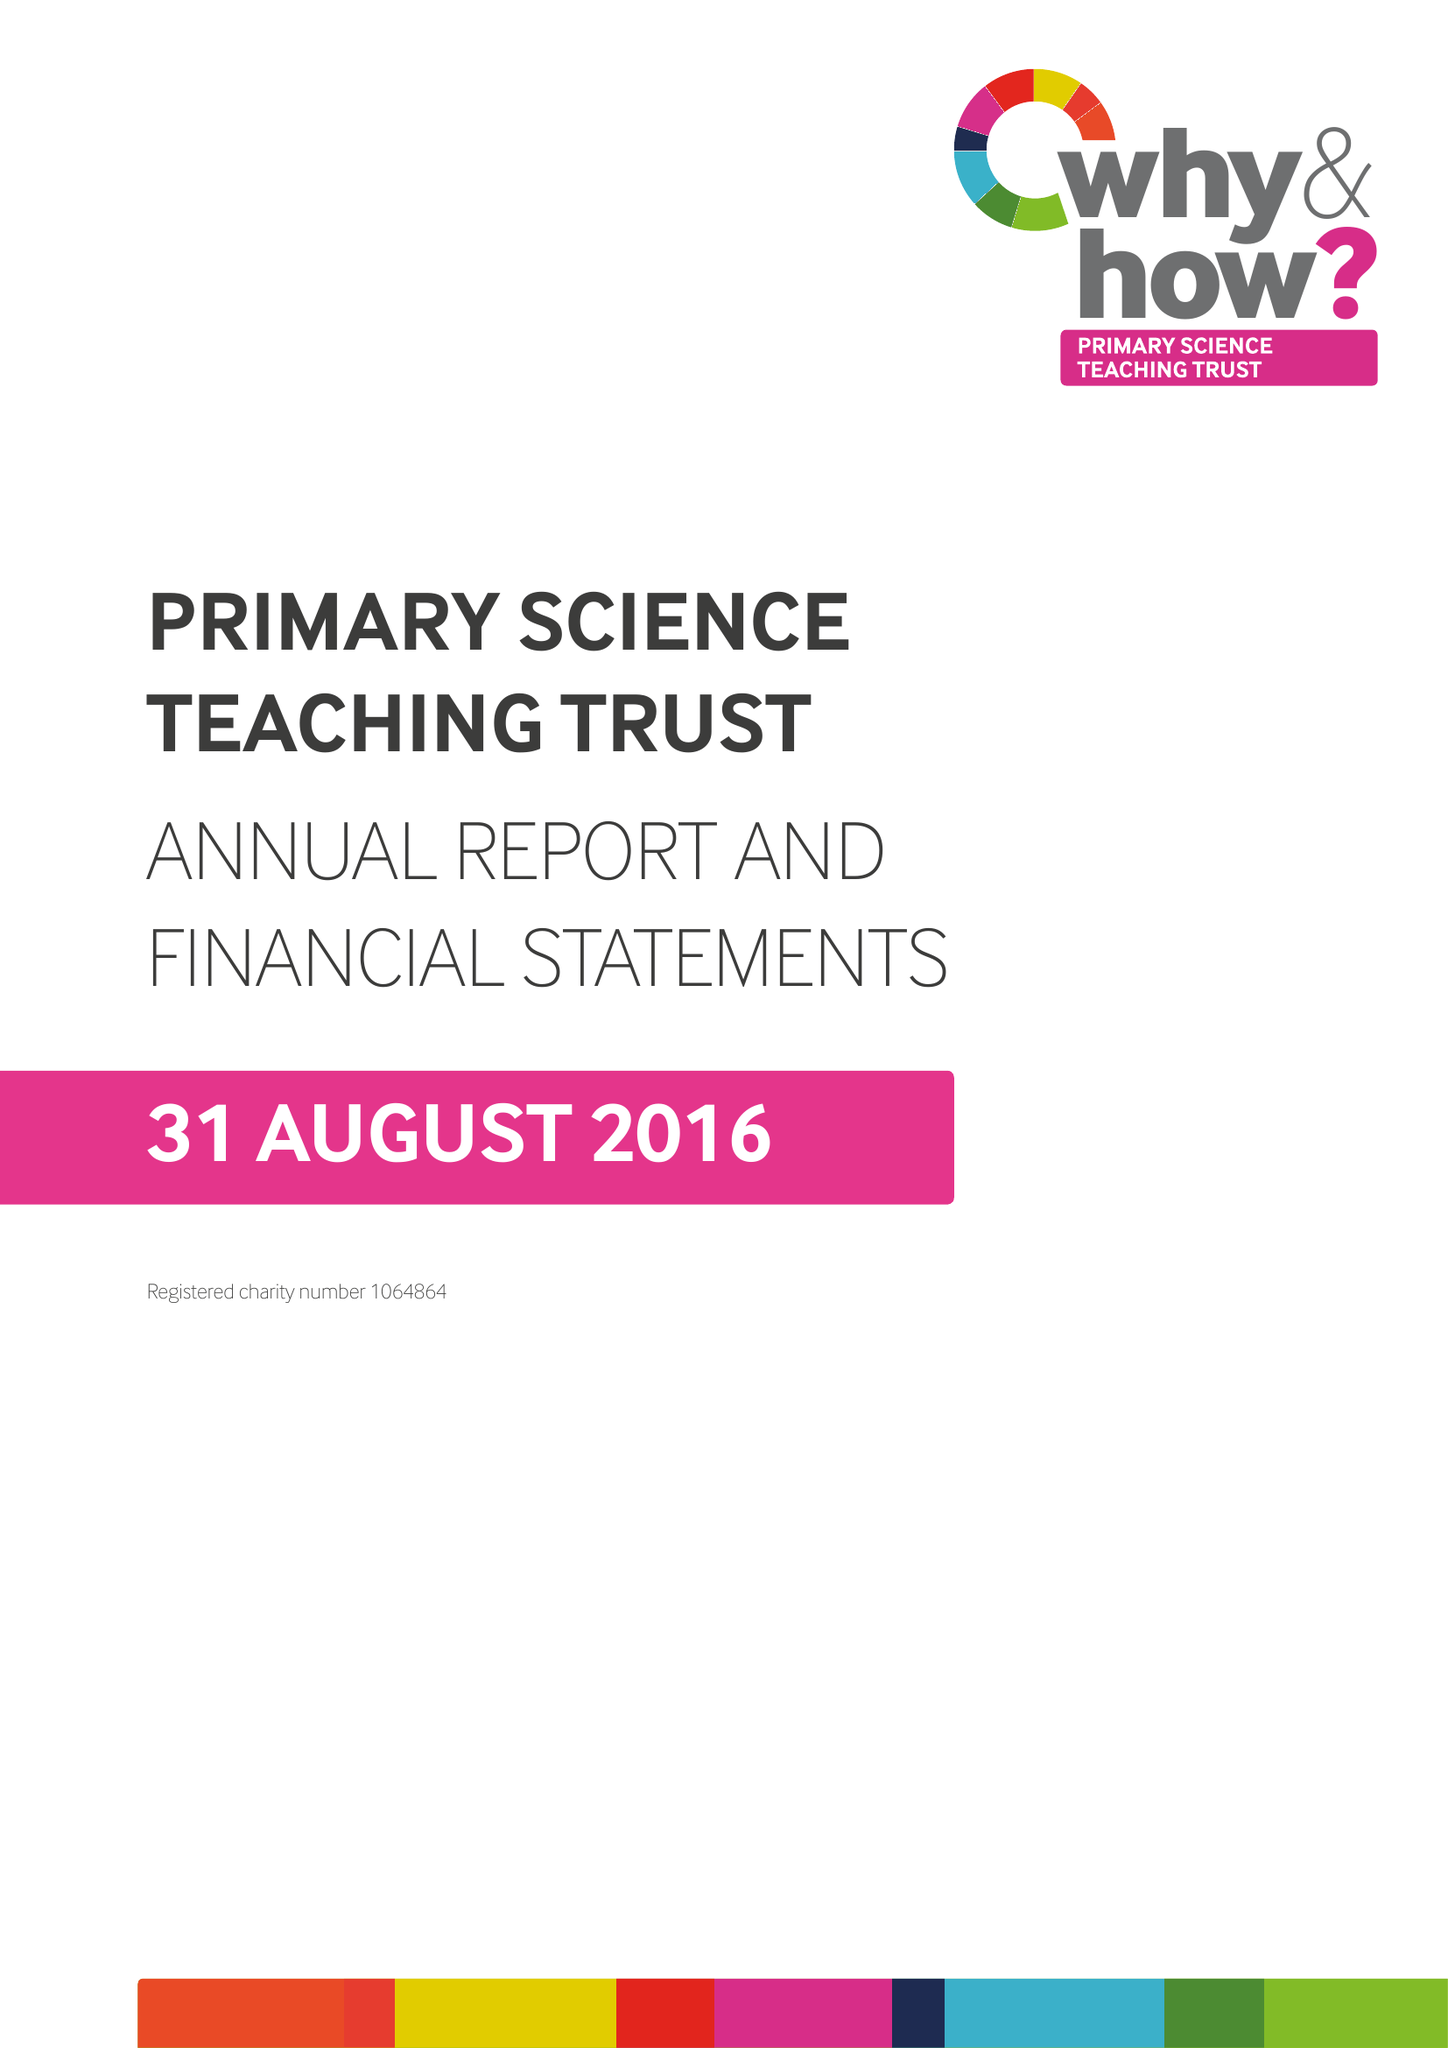What is the value for the report_date?
Answer the question using a single word or phrase. 2016-08-31 